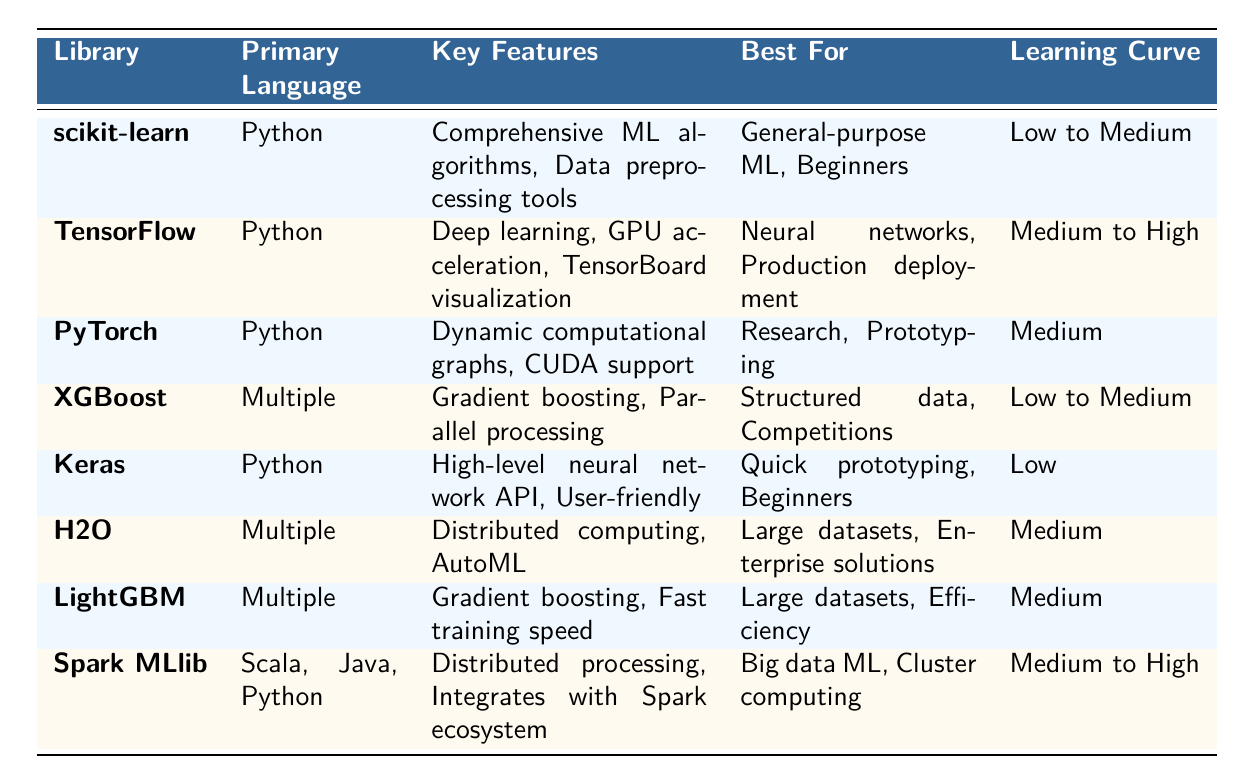What programming language is TensorFlow written in? The table indicates that the primary language of TensorFlow is Python.
Answer: Python Which library is best suited for beginners? In the "Best For" column, both scikit-learn and Keras are listed for beginners.
Answer: scikit-learn, Keras How many libraries are optimized for large datasets? The libraries optimized for large datasets according to the "Best For" column are H2O, LightGBM, and Spark MLlib. This makes a total of three libraries.
Answer: 3 Is Keras suitable for quick prototyping? The table mentions that Keras is indeed best for quick prototyping in the "Best For" column, therefore the statement is true.
Answer: Yes Which library has the highest learning curve? TensorFlow and Spark MLlib both have a learning curve categorized as Medium to High, so the answer requires checking and comparing them.
Answer: TensorFlow, Spark MLlib What key feature is common between XGBoost and LightGBM? Both libraries mention "Gradient boosting" as a key feature in their respective rows of the "Key Features" column.
Answer: Gradient boosting Among the libraries listed, which one provides automatic machine learning capabilities? H2O is the only library mentioned in the table that has "AutoML" as one of its key features.
Answer: H2O If a user is a novice, which libraries should they consider using? Based on the "Best For" column, scikit-learn and Keras are recommended for beginners, so these two libraries should be considered.
Answer: scikit-learn, Keras What are the primary languages used by libraries that provide distributed computing features? The libraries that provide distributed computing features are H2O and Spark MLlib, which use multiple primary languages as indicated in the "Primary Language" column of the table. H2O uses multiple languages, while Spark MLlib uses Scala, Java, and Python.
Answer: H2O, Spark MLlib How does the learning curve of scikit-learn compare to that of TensorFlow? The table indicates that scikit-learn has a low to medium learning curve, whereas TensorFlow has a medium to high learning curve, showing that TensorFlow has a steeper learning curve than scikit-learn.
Answer: TensorFlow has a steeper learning curve than scikit-learn 